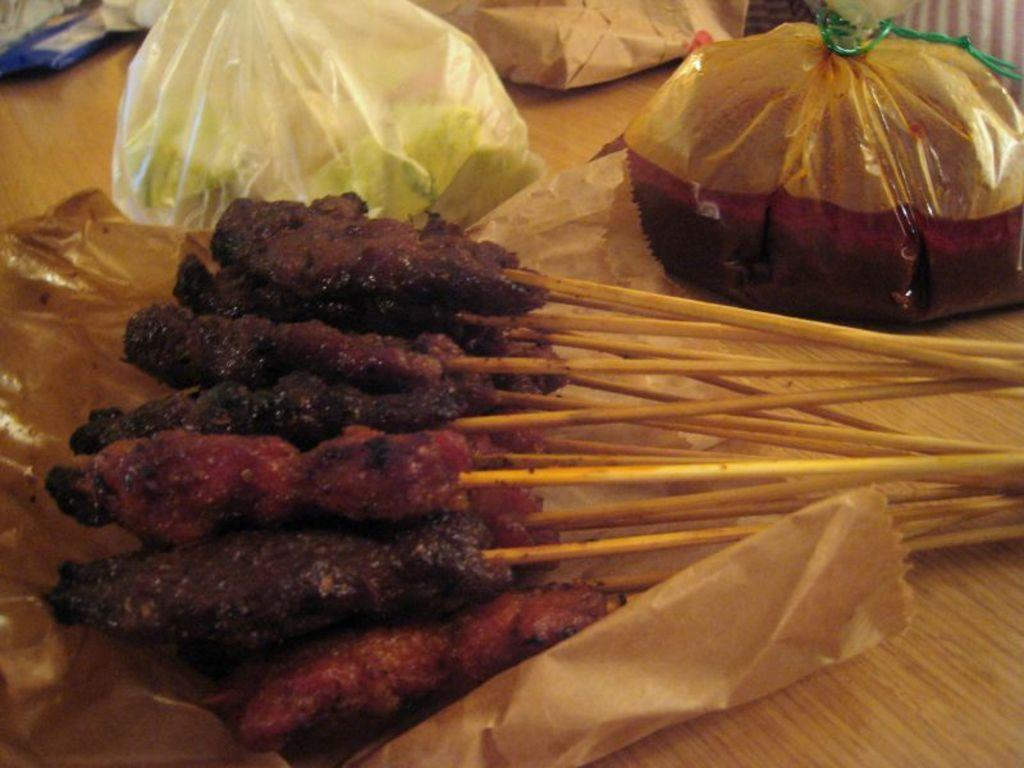What types of food items can be seen in the image? There are food items in the image, including meat sticks. What else is present in the image besides the food items? There are covers in the image. What type of table is visible in the image? The wooden table is present in the image. How does the car in the image affect the food items? There is no car present in the image, so it cannot affect the food items. 